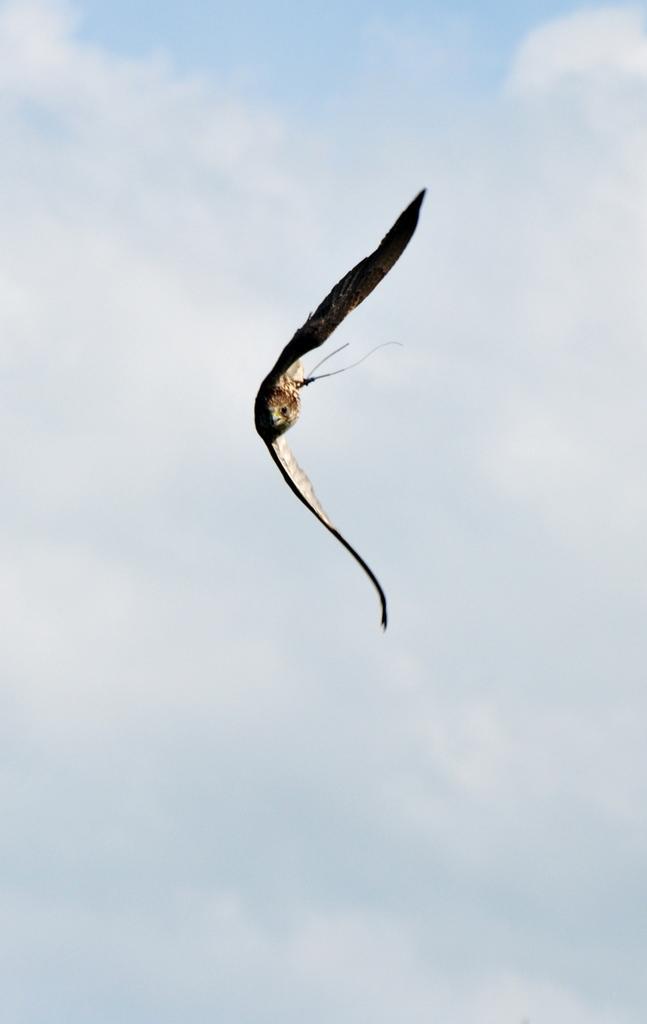How would you summarize this image in a sentence or two? In this image we can see a flying bird and in the background, we can see the sky. 